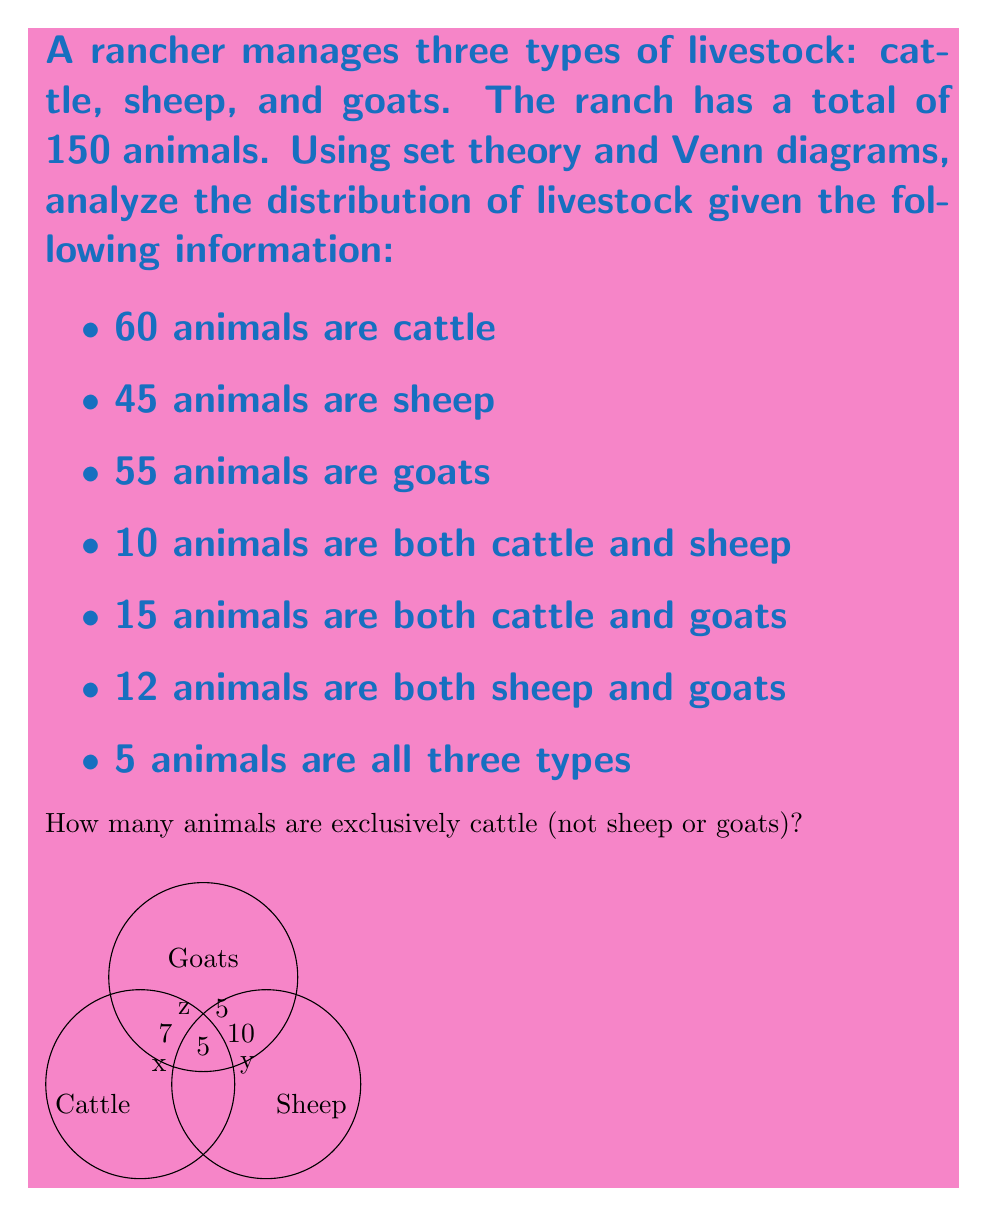What is the answer to this math problem? Let's approach this step-by-step using set theory and the given Venn diagram:

1) Let's define our sets:
   C: Cattle
   S: Sheep
   G: Goats

2) We're given:
   $|C| = 60$, $|S| = 45$, $|G| = 55$
   $|C \cap S| = 10$, $|C \cap G| = 15$, $|S \cap G| = 12$
   $|C \cap S \cap G| = 5$

3) Let x be the number of animals that are exclusively cattle.
   Let y be the number of animals that are exclusively sheep.
   Let z be the number of animals that are exclusively goats.

4) From the Venn diagram, we can write:
   $x + 5 + 7 + 5 + 10 + 5 + 15 = 60$ (total cattle)
   $y + 5 + 10 + 5 + 7 + 5 + 12 = 45$ (total sheep)
   $z + 5 + 15 + 5 + 7 + 5 + 12 = 55$ (total goats)

5) From the first equation:
   $x + 47 = 60$
   $x = 13$

Therefore, 13 animals are exclusively cattle.

We can verify this result:
Total animals = $13 + 5 + 7 + 5 + 10 + 5 + 15 + y + z = 150$
$60 + y + z = 150$
$y + z = 90$

This matches with the sum of sheep and goats exclusive regions and their intersection:
$y + 12 + 5 + z = 90$

Thus, our solution is consistent with all given information.
Answer: 13 